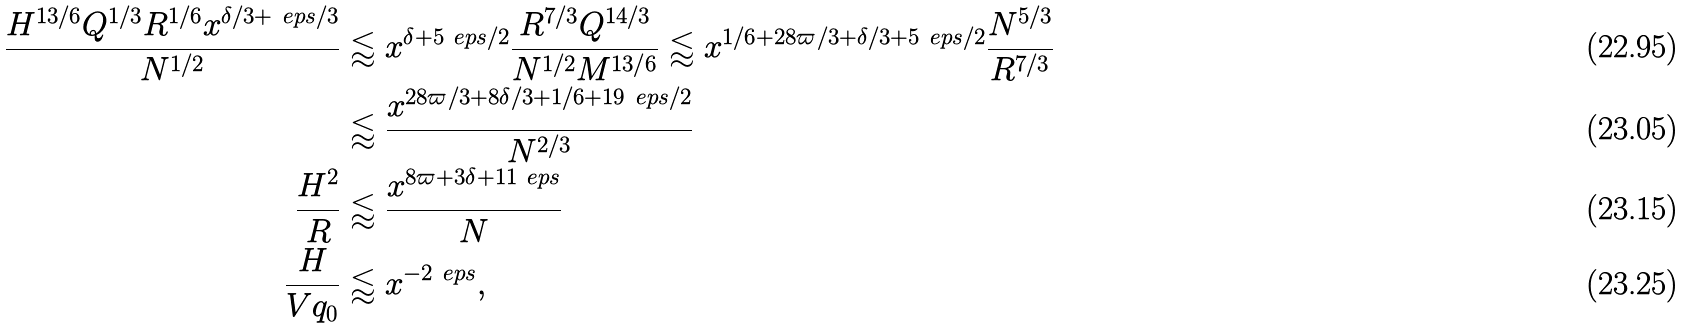<formula> <loc_0><loc_0><loc_500><loc_500>\frac { H ^ { 1 3 / 6 } Q ^ { 1 / 3 } R ^ { 1 / 6 } x ^ { \delta / 3 + \ e p s / 3 } } { N ^ { 1 / 2 } } & \lessapprox x ^ { \delta + 5 \ e p s / 2 } \frac { R ^ { 7 / 3 } Q ^ { 1 4 / 3 } } { N ^ { 1 / 2 } M ^ { 1 3 / 6 } } \lessapprox x ^ { 1 / 6 + 2 8 \varpi / 3 + \delta / 3 + 5 \ e p s / 2 } \frac { N ^ { 5 / 3 } } { R ^ { 7 / 3 } } \\ & \lessapprox \frac { x ^ { 2 8 \varpi / 3 + 8 \delta / 3 + 1 / 6 + 1 9 \ e p s / 2 } } { N ^ { 2 / 3 } } \\ \frac { H ^ { 2 } } { R } & \lessapprox \frac { x ^ { 8 \varpi + 3 \delta + 1 1 \ e p s } } { N } \\ \frac { H } { V q _ { 0 } } & \lessapprox x ^ { - 2 \ e p s } ,</formula> 